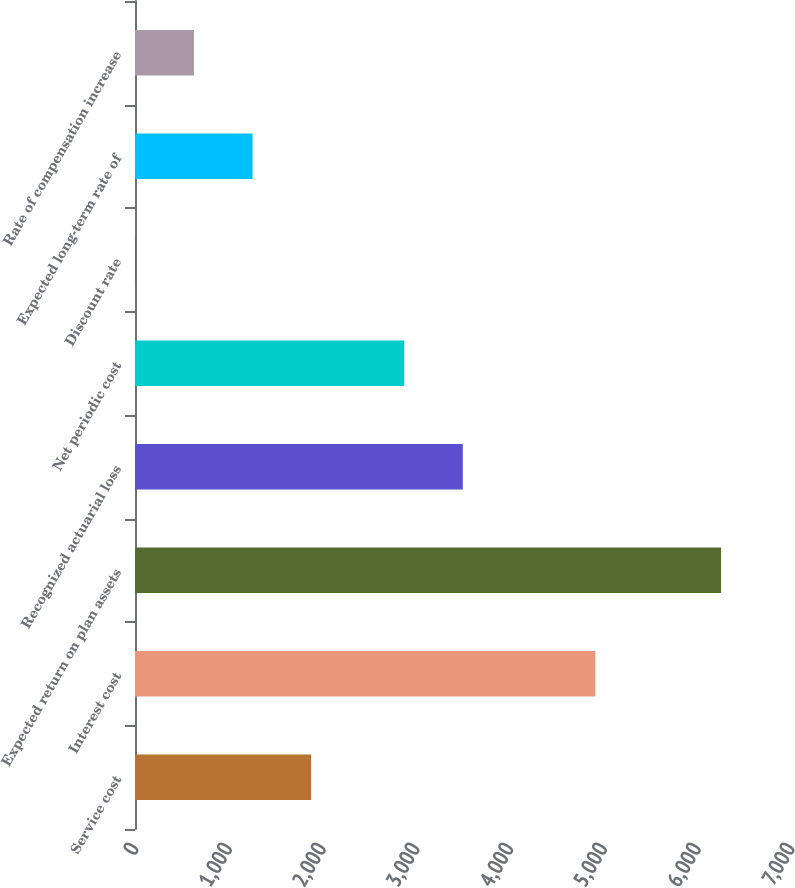Convert chart to OTSL. <chart><loc_0><loc_0><loc_500><loc_500><bar_chart><fcel>Service cost<fcel>Interest cost<fcel>Expected return on plan assets<fcel>Recognized actuarial loss<fcel>Net periodic cost<fcel>Discount rate<fcel>Expected long-term rate of<fcel>Rate of compensation increase<nl><fcel>1878.98<fcel>4912<fcel>6254<fcel>3498.01<fcel>2873<fcel>3.95<fcel>1253.97<fcel>628.96<nl></chart> 